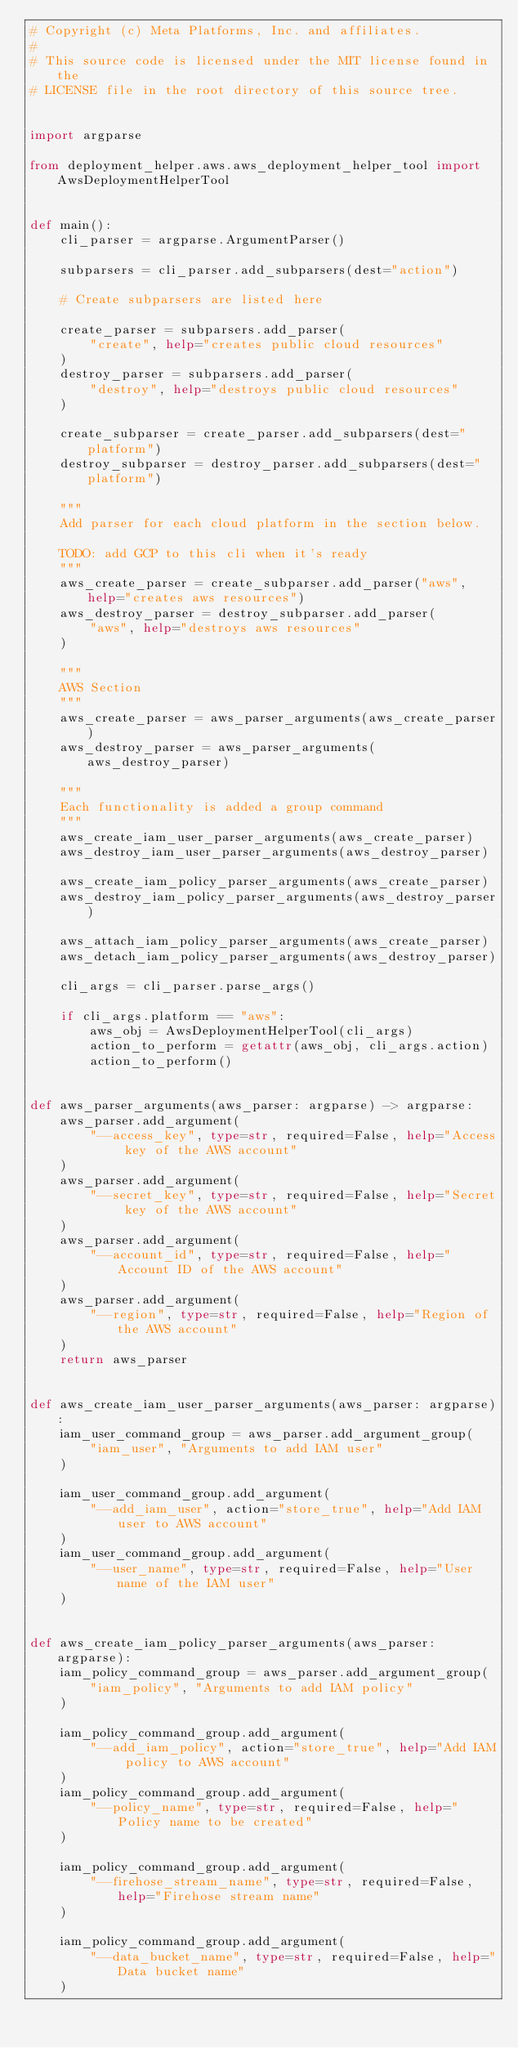<code> <loc_0><loc_0><loc_500><loc_500><_Python_># Copyright (c) Meta Platforms, Inc. and affiliates.
#
# This source code is licensed under the MIT license found in the
# LICENSE file in the root directory of this source tree.


import argparse

from deployment_helper.aws.aws_deployment_helper_tool import AwsDeploymentHelperTool


def main():
    cli_parser = argparse.ArgumentParser()

    subparsers = cli_parser.add_subparsers(dest="action")

    # Create subparsers are listed here

    create_parser = subparsers.add_parser(
        "create", help="creates public cloud resources"
    )
    destroy_parser = subparsers.add_parser(
        "destroy", help="destroys public cloud resources"
    )

    create_subparser = create_parser.add_subparsers(dest="platform")
    destroy_subparser = destroy_parser.add_subparsers(dest="platform")

    """
    Add parser for each cloud platform in the section below.

    TODO: add GCP to this cli when it's ready
    """
    aws_create_parser = create_subparser.add_parser("aws", help="creates aws resources")
    aws_destroy_parser = destroy_subparser.add_parser(
        "aws", help="destroys aws resources"
    )

    """
    AWS Section
    """
    aws_create_parser = aws_parser_arguments(aws_create_parser)
    aws_destroy_parser = aws_parser_arguments(aws_destroy_parser)

    """
    Each functionality is added a group command
    """
    aws_create_iam_user_parser_arguments(aws_create_parser)
    aws_destroy_iam_user_parser_arguments(aws_destroy_parser)

    aws_create_iam_policy_parser_arguments(aws_create_parser)
    aws_destroy_iam_policy_parser_arguments(aws_destroy_parser)

    aws_attach_iam_policy_parser_arguments(aws_create_parser)
    aws_detach_iam_policy_parser_arguments(aws_destroy_parser)

    cli_args = cli_parser.parse_args()

    if cli_args.platform == "aws":
        aws_obj = AwsDeploymentHelperTool(cli_args)
        action_to_perform = getattr(aws_obj, cli_args.action)
        action_to_perform()


def aws_parser_arguments(aws_parser: argparse) -> argparse:
    aws_parser.add_argument(
        "--access_key", type=str, required=False, help="Access key of the AWS account"
    )
    aws_parser.add_argument(
        "--secret_key", type=str, required=False, help="Secret key of the AWS account"
    )
    aws_parser.add_argument(
        "--account_id", type=str, required=False, help="Account ID of the AWS account"
    )
    aws_parser.add_argument(
        "--region", type=str, required=False, help="Region of the AWS account"
    )
    return aws_parser


def aws_create_iam_user_parser_arguments(aws_parser: argparse):
    iam_user_command_group = aws_parser.add_argument_group(
        "iam_user", "Arguments to add IAM user"
    )

    iam_user_command_group.add_argument(
        "--add_iam_user", action="store_true", help="Add IAM user to AWS account"
    )
    iam_user_command_group.add_argument(
        "--user_name", type=str, required=False, help="User name of the IAM user"
    )


def aws_create_iam_policy_parser_arguments(aws_parser: argparse):
    iam_policy_command_group = aws_parser.add_argument_group(
        "iam_policy", "Arguments to add IAM policy"
    )

    iam_policy_command_group.add_argument(
        "--add_iam_policy", action="store_true", help="Add IAM policy to AWS account"
    )
    iam_policy_command_group.add_argument(
        "--policy_name", type=str, required=False, help="Policy name to be created"
    )

    iam_policy_command_group.add_argument(
        "--firehose_stream_name", type=str, required=False, help="Firehose stream name"
    )

    iam_policy_command_group.add_argument(
        "--data_bucket_name", type=str, required=False, help="Data bucket name"
    )
</code> 